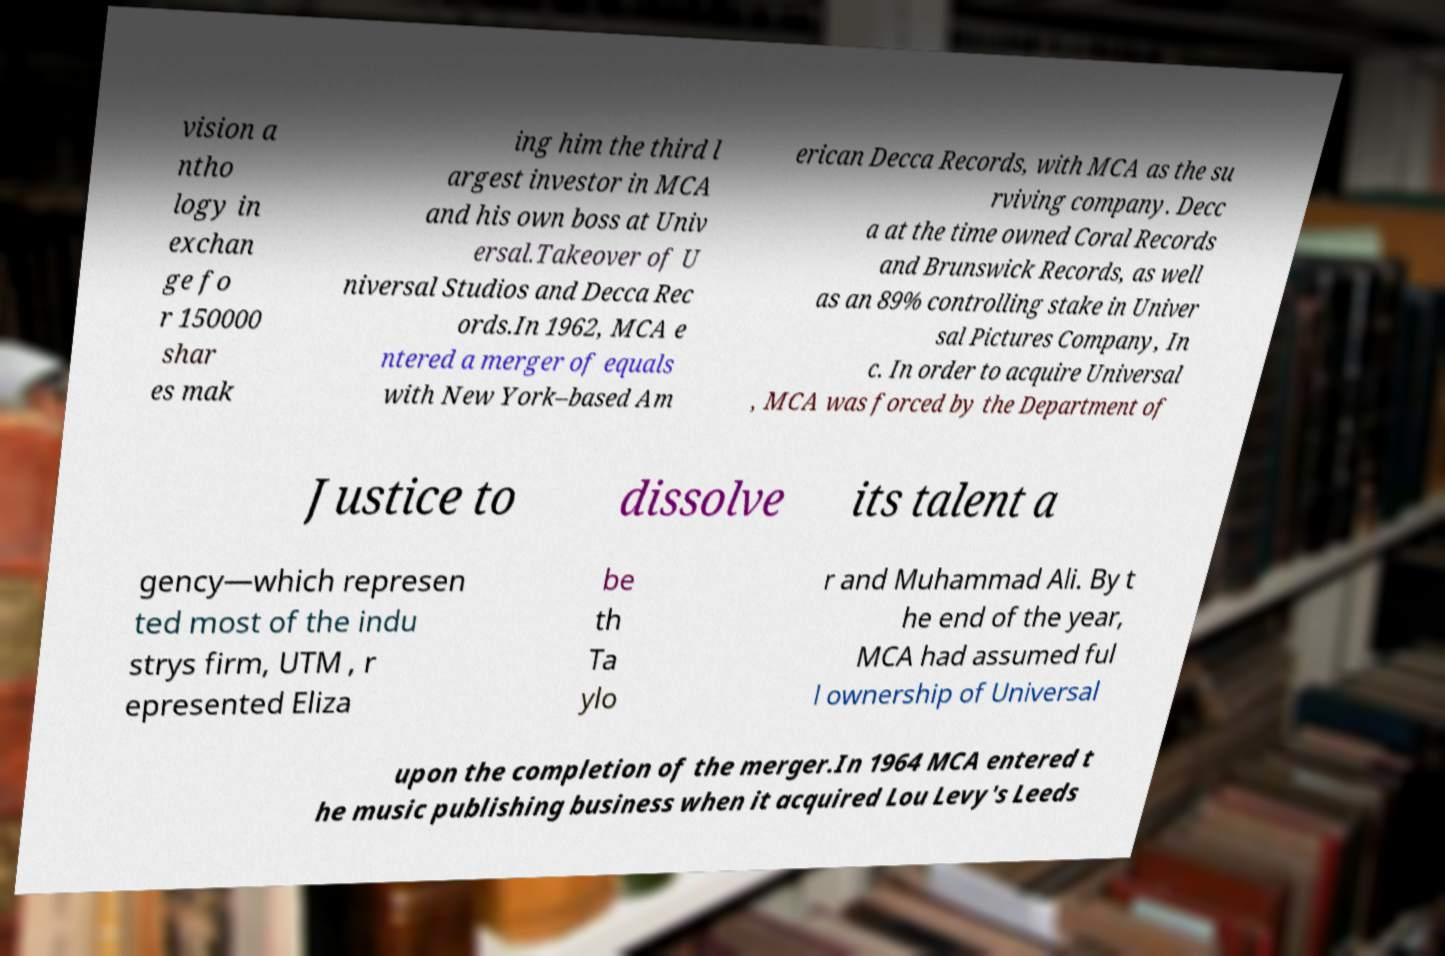For documentation purposes, I need the text within this image transcribed. Could you provide that? vision a ntho logy in exchan ge fo r 150000 shar es mak ing him the third l argest investor in MCA and his own boss at Univ ersal.Takeover of U niversal Studios and Decca Rec ords.In 1962, MCA e ntered a merger of equals with New York–based Am erican Decca Records, with MCA as the su rviving company. Decc a at the time owned Coral Records and Brunswick Records, as well as an 89% controlling stake in Univer sal Pictures Company, In c. In order to acquire Universal , MCA was forced by the Department of Justice to dissolve its talent a gency—which represen ted most of the indu strys firm, UTM , r epresented Eliza be th Ta ylo r and Muhammad Ali. By t he end of the year, MCA had assumed ful l ownership of Universal upon the completion of the merger.In 1964 MCA entered t he music publishing business when it acquired Lou Levy's Leeds 